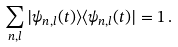<formula> <loc_0><loc_0><loc_500><loc_500>\sum _ { n , l } | \psi _ { n , l } ( t ) \rangle \langle \psi _ { n , l } ( t ) | = 1 \, .</formula> 